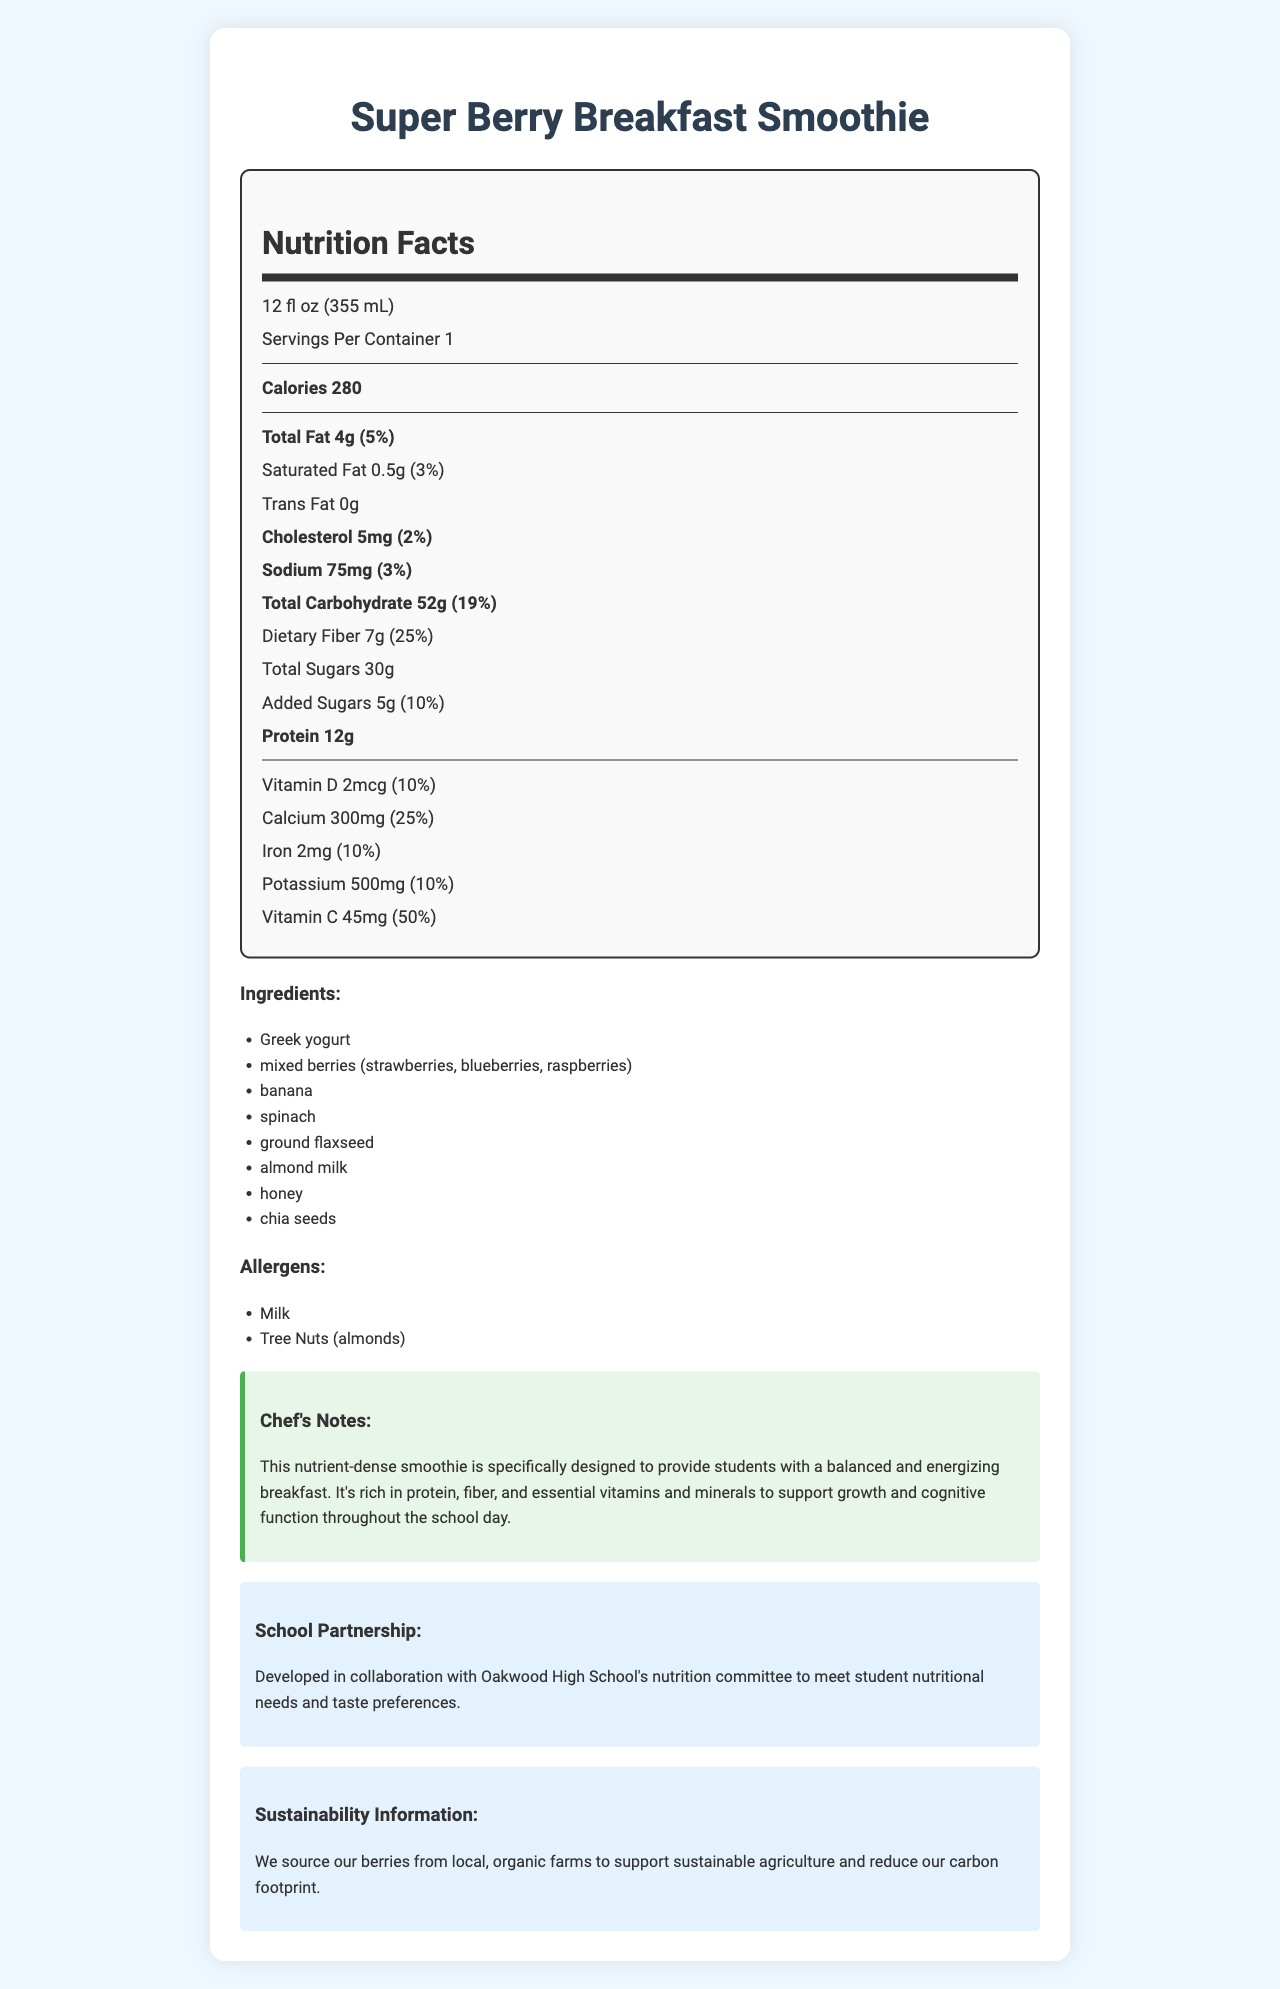what is the serving size of the Super Berry Breakfast Smoothie? The serving size is explicitly mentioned as 12 fl oz (355 mL) in the nutrition facts section.
Answer: 12 fl oz (355 mL) how many calories are in a serving? The document states that there are 280 calories per serving.
Answer: 280 how much protein does the smoothie contain? The document lists the amount of protein per serving as 12g.
Answer: 12g what is the total amount of dietary fiber in one serving of the smoothie? The document states that the total amount of dietary fiber is 7g.
Answer: 7g what allergens are present in the smoothie? The allergens are listed under the allergens section as Milk and Tree Nuts (almonds).
Answer: Milk, Tree Nuts (almonds) how many grams of total sugars does the smoothie have? The document specifies that the total sugars content is 30g per serving.
Answer: 30g how much calcium is in one serving of the smoothie? It's mentioned in the document that the calcium content is 300mg per serving.
Answer: 300mg how much iron is in one serving of the smoothie? A. 1mg B. 2mg C. 3mg D. 4mg The document states that there are 2mg of iron per serving.
Answer: B what is the daily value percentage of total fat per serving? A. 3% B. 5% C. 7% D. 10% The document mentions that the daily value percentage of total fat per serving is 5%.
Answer: B does the smoothie contain any trans fat? The document clearly states that the trans fat content is 0g.
Answer: No what makes this smoothie nutrient-dense? The chef's notes mention that the smoothie is rich in protein, fiber, and essential vitamins and minerals, making it nutrient-dense.
Answer: It is rich in protein, fiber, and essential vitamins and minerals explain the purpose of this document in your own words. The document includes detailed nutritional information, ingredients, chef's notes, partnership details, and sustainability information, aiming to inform readers about the smoothie’s health benefits and background.
Answer: The document provides the nutrition facts, ingredients, allergen information, and additional notes about the Super Berry Breakfast Smoothie. It highlights the smoothie’s nutritional benefits, its development in partnership with a school, and its sustainability aspects. are there any unlisted ingredients used in the smoothie? The document lists specific ingredients, but there could potentially be unlisted ingredients not mentioned in the document.
Answer: Cannot be determined 